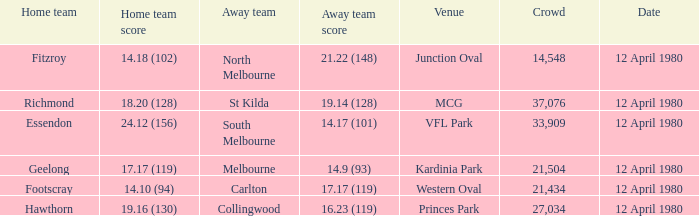Who was North Melbourne's home opponent? Fitzroy. 